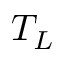<formula> <loc_0><loc_0><loc_500><loc_500>T _ { L }</formula> 